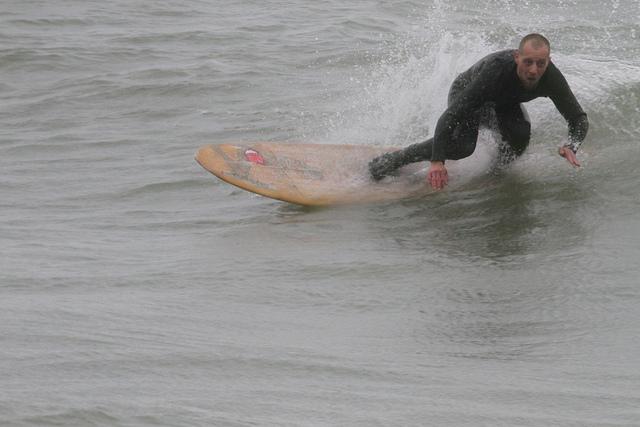Is this man happy?
Give a very brief answer. Yes. Who is surfing?
Write a very short answer. Man. What race is the man on the surf board?
Answer briefly. White. Is there a reflection on the water?
Be succinct. Yes. Whose mouth is open?
Write a very short answer. Surfer. 